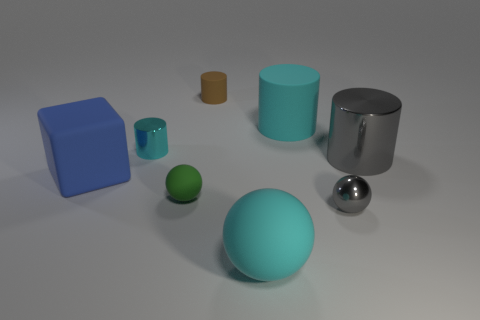What number of tiny gray balls have the same material as the big gray cylinder?
Provide a short and direct response. 1. How many rubber things are blue blocks or green spheres?
Your answer should be very brief. 2. Does the metallic thing in front of the gray cylinder have the same shape as the cyan matte object that is in front of the small metal cylinder?
Offer a very short reply. Yes. The thing that is both right of the blue matte object and on the left side of the tiny green matte thing is what color?
Keep it short and to the point. Cyan. There is a metal cylinder to the left of the cyan rubber sphere; is its size the same as the gray metallic thing that is behind the large blue object?
Make the answer very short. No. What number of balls have the same color as the small shiny cylinder?
Your response must be concise. 1. How many small objects are yellow cylinders or rubber cylinders?
Your answer should be compact. 1. Does the sphere to the right of the cyan ball have the same material as the big gray cylinder?
Offer a terse response. Yes. There is a matte cylinder in front of the small brown cylinder; what is its color?
Provide a short and direct response. Cyan. Is there a brown cylinder that has the same size as the cyan matte cylinder?
Make the answer very short. No. 